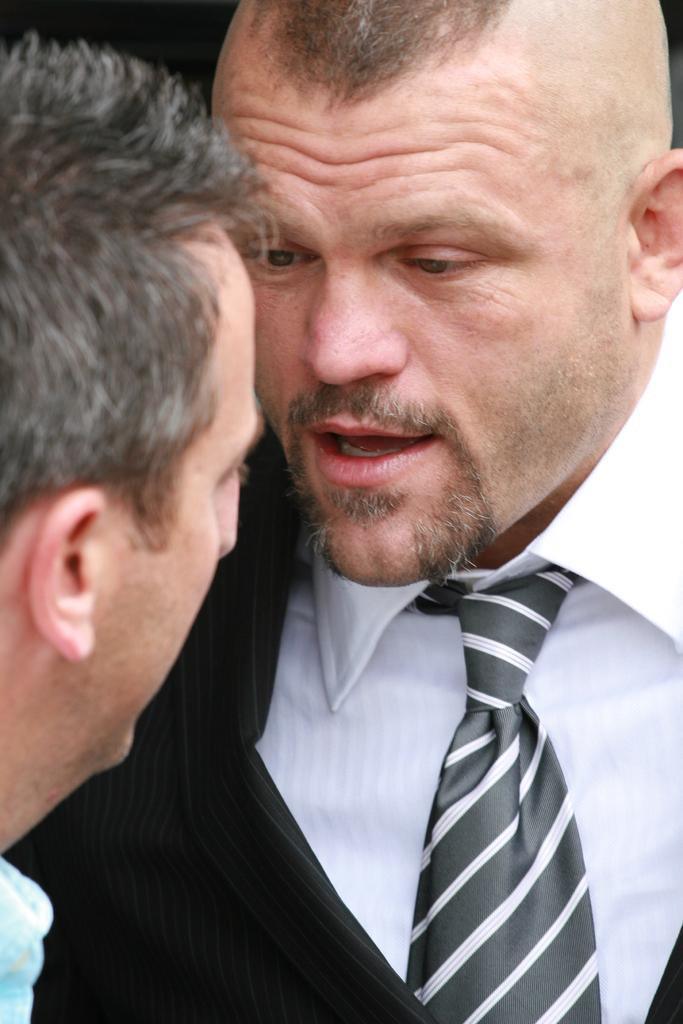What is the man in the image wearing? The man is wearing a white color shirt and a black color blazer. Where is the man located in the image? The man is in the middle of the image. Can you describe the other person in the image? There is another person on the left side of the image. What type of quartz can be seen in the man's hand in the image? There is no quartz present in the image; the man is not holding any quartz. Is the other person in the image a crook? There is no information provided about the other person's character or occupation, so it cannot be determined if they are a crook. 